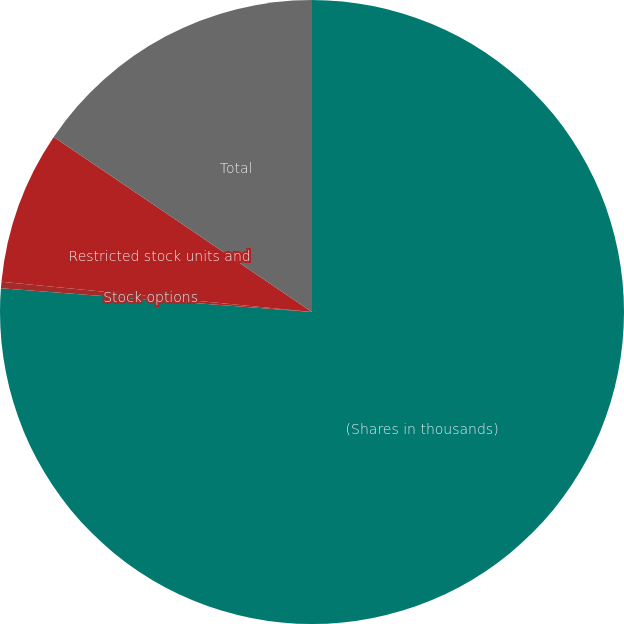Convert chart to OTSL. <chart><loc_0><loc_0><loc_500><loc_500><pie_chart><fcel>(Shares in thousands)<fcel>Stock options<fcel>Restricted stock units and<fcel>Total<nl><fcel>76.21%<fcel>0.34%<fcel>7.93%<fcel>15.52%<nl></chart> 